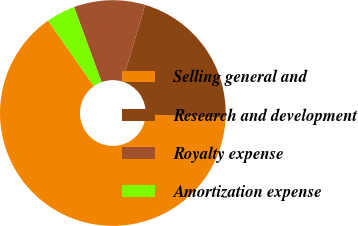Convert chart to OTSL. <chart><loc_0><loc_0><loc_500><loc_500><pie_chart><fcel>Selling general and<fcel>Research and development<fcel>Royalty expense<fcel>Amortization expense<nl><fcel>64.58%<fcel>21.04%<fcel>10.21%<fcel>4.17%<nl></chart> 